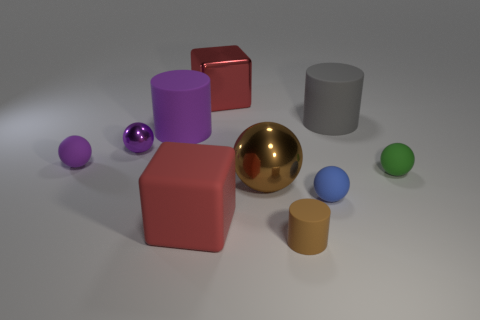Is the number of tiny shiny objects that are on the right side of the gray thing less than the number of small blue rubber things left of the big purple matte cylinder?
Ensure brevity in your answer.  No. There is a red rubber cube; is its size the same as the brown thing behind the small brown cylinder?
Offer a terse response. Yes. The small matte thing that is both to the right of the brown cylinder and left of the green matte object has what shape?
Give a very brief answer. Sphere. There is a green sphere that is the same material as the purple cylinder; what size is it?
Ensure brevity in your answer.  Small. There is a small matte cylinder in front of the small purple rubber thing; what number of big cylinders are to the left of it?
Your response must be concise. 1. Is the cylinder on the right side of the tiny brown rubber object made of the same material as the brown cylinder?
Your answer should be compact. Yes. Are there any other things that are made of the same material as the large purple cylinder?
Your response must be concise. Yes. What size is the rubber object in front of the red object in front of the metallic cube?
Keep it short and to the point. Small. There is a blue ball right of the tiny thing in front of the red block that is in front of the blue thing; what size is it?
Ensure brevity in your answer.  Small. Is the shape of the small matte thing left of the small brown object the same as the big metallic thing behind the purple rubber cylinder?
Provide a succinct answer. No. 